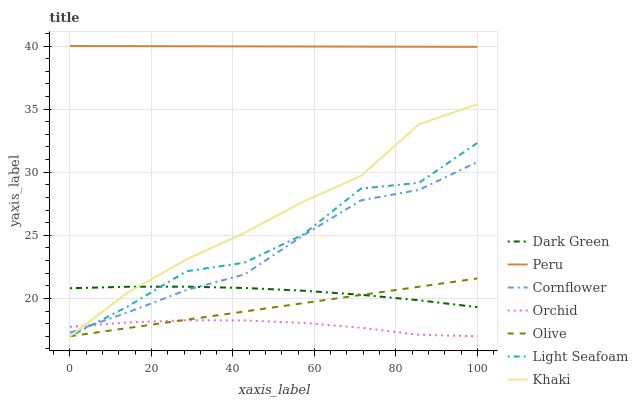Does Orchid have the minimum area under the curve?
Answer yes or no. Yes. Does Peru have the maximum area under the curve?
Answer yes or no. Yes. Does Khaki have the minimum area under the curve?
Answer yes or no. No. Does Khaki have the maximum area under the curve?
Answer yes or no. No. Is Olive the smoothest?
Answer yes or no. Yes. Is Light Seafoam the roughest?
Answer yes or no. Yes. Is Khaki the smoothest?
Answer yes or no. No. Is Khaki the roughest?
Answer yes or no. No. Does Khaki have the lowest value?
Answer yes or no. Yes. Does Dark Green have the lowest value?
Answer yes or no. No. Does Peru have the highest value?
Answer yes or no. Yes. Does Khaki have the highest value?
Answer yes or no. No. Is Olive less than Cornflower?
Answer yes or no. Yes. Is Dark Green greater than Orchid?
Answer yes or no. Yes. Does Orchid intersect Khaki?
Answer yes or no. Yes. Is Orchid less than Khaki?
Answer yes or no. No. Is Orchid greater than Khaki?
Answer yes or no. No. Does Olive intersect Cornflower?
Answer yes or no. No. 